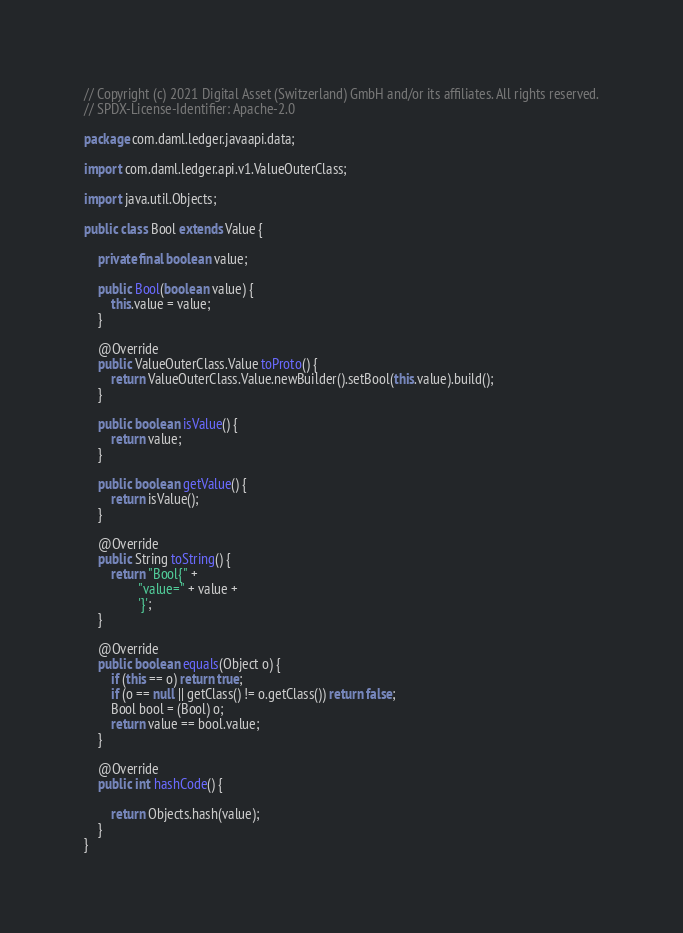<code> <loc_0><loc_0><loc_500><loc_500><_Java_>// Copyright (c) 2021 Digital Asset (Switzerland) GmbH and/or its affiliates. All rights reserved.
// SPDX-License-Identifier: Apache-2.0

package com.daml.ledger.javaapi.data;

import com.daml.ledger.api.v1.ValueOuterClass;

import java.util.Objects;

public class Bool extends Value {

    private final boolean value;

    public Bool(boolean value) {
        this.value = value;
    }

    @Override
    public ValueOuterClass.Value toProto() {
        return ValueOuterClass.Value.newBuilder().setBool(this.value).build();
    }

    public boolean isValue() {
        return value;
    }

    public boolean getValue() {
        return isValue();
    }

    @Override
    public String toString() {
        return "Bool{" +
                "value=" + value +
                '}';
    }

    @Override
    public boolean equals(Object o) {
        if (this == o) return true;
        if (o == null || getClass() != o.getClass()) return false;
        Bool bool = (Bool) o;
        return value == bool.value;
    }

    @Override
    public int hashCode() {

        return Objects.hash(value);
    }
}
</code> 